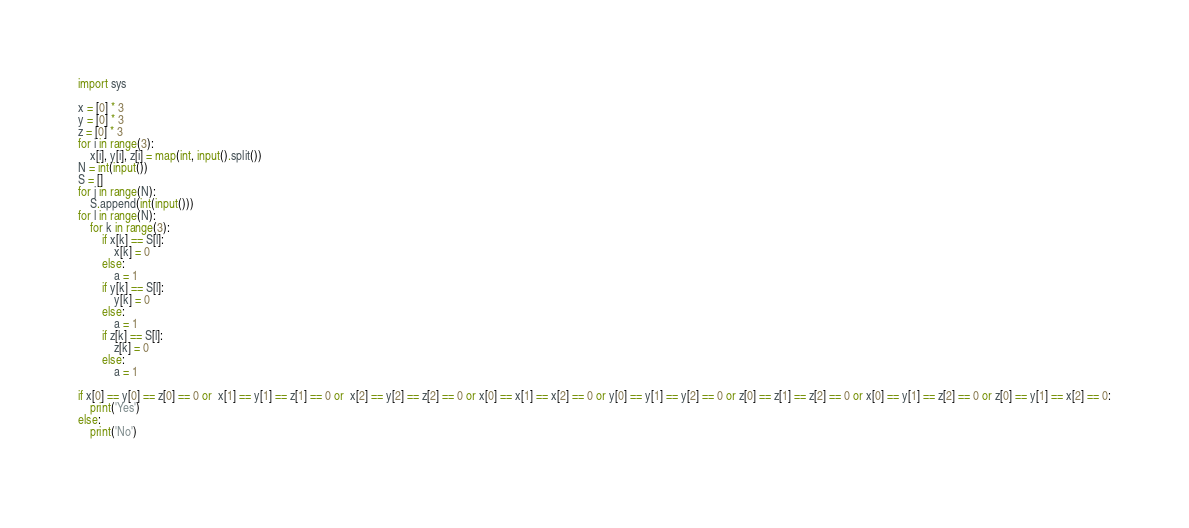Convert code to text. <code><loc_0><loc_0><loc_500><loc_500><_Python_>import sys

x = [0] * 3
y = [0] * 3
z = [0] * 3
for i in range(3):
    x[i], y[i], z[i] = map(int, input().split())
N = int(input())
S = []
for j in range(N):
    S.append(int(input())) 
for l in range(N):
    for k in range(3):
        if x[k] == S[l]:
            x[k] = 0
        else:
            a = 1
        if y[k] == S[l]:
            y[k] = 0
        else:
            a = 1
        if z[k] == S[l]:
            z[k] = 0
        else:
            a = 1
        
if x[0] == y[0] == z[0] == 0 or  x[1] == y[1] == z[1] == 0 or  x[2] == y[2] == z[2] == 0 or x[0] == x[1] == x[2] == 0 or y[0] == y[1] == y[2] == 0 or z[0] == z[1] == z[2] == 0 or x[0] == y[1] == z[2] == 0 or z[0] == y[1] == x[2] == 0:
    print('Yes')
else:
    print('No')
        </code> 